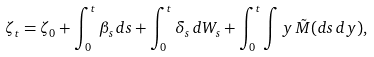<formula> <loc_0><loc_0><loc_500><loc_500>\zeta _ { t } = \zeta _ { 0 } + \int _ { 0 } ^ { t } \beta _ { s } \, d s + \int _ { 0 } ^ { t } \delta _ { s } \, d W _ { s } + \int _ { 0 } ^ { t } \int y \, \tilde { M } ( d s \, d y ) ,</formula> 